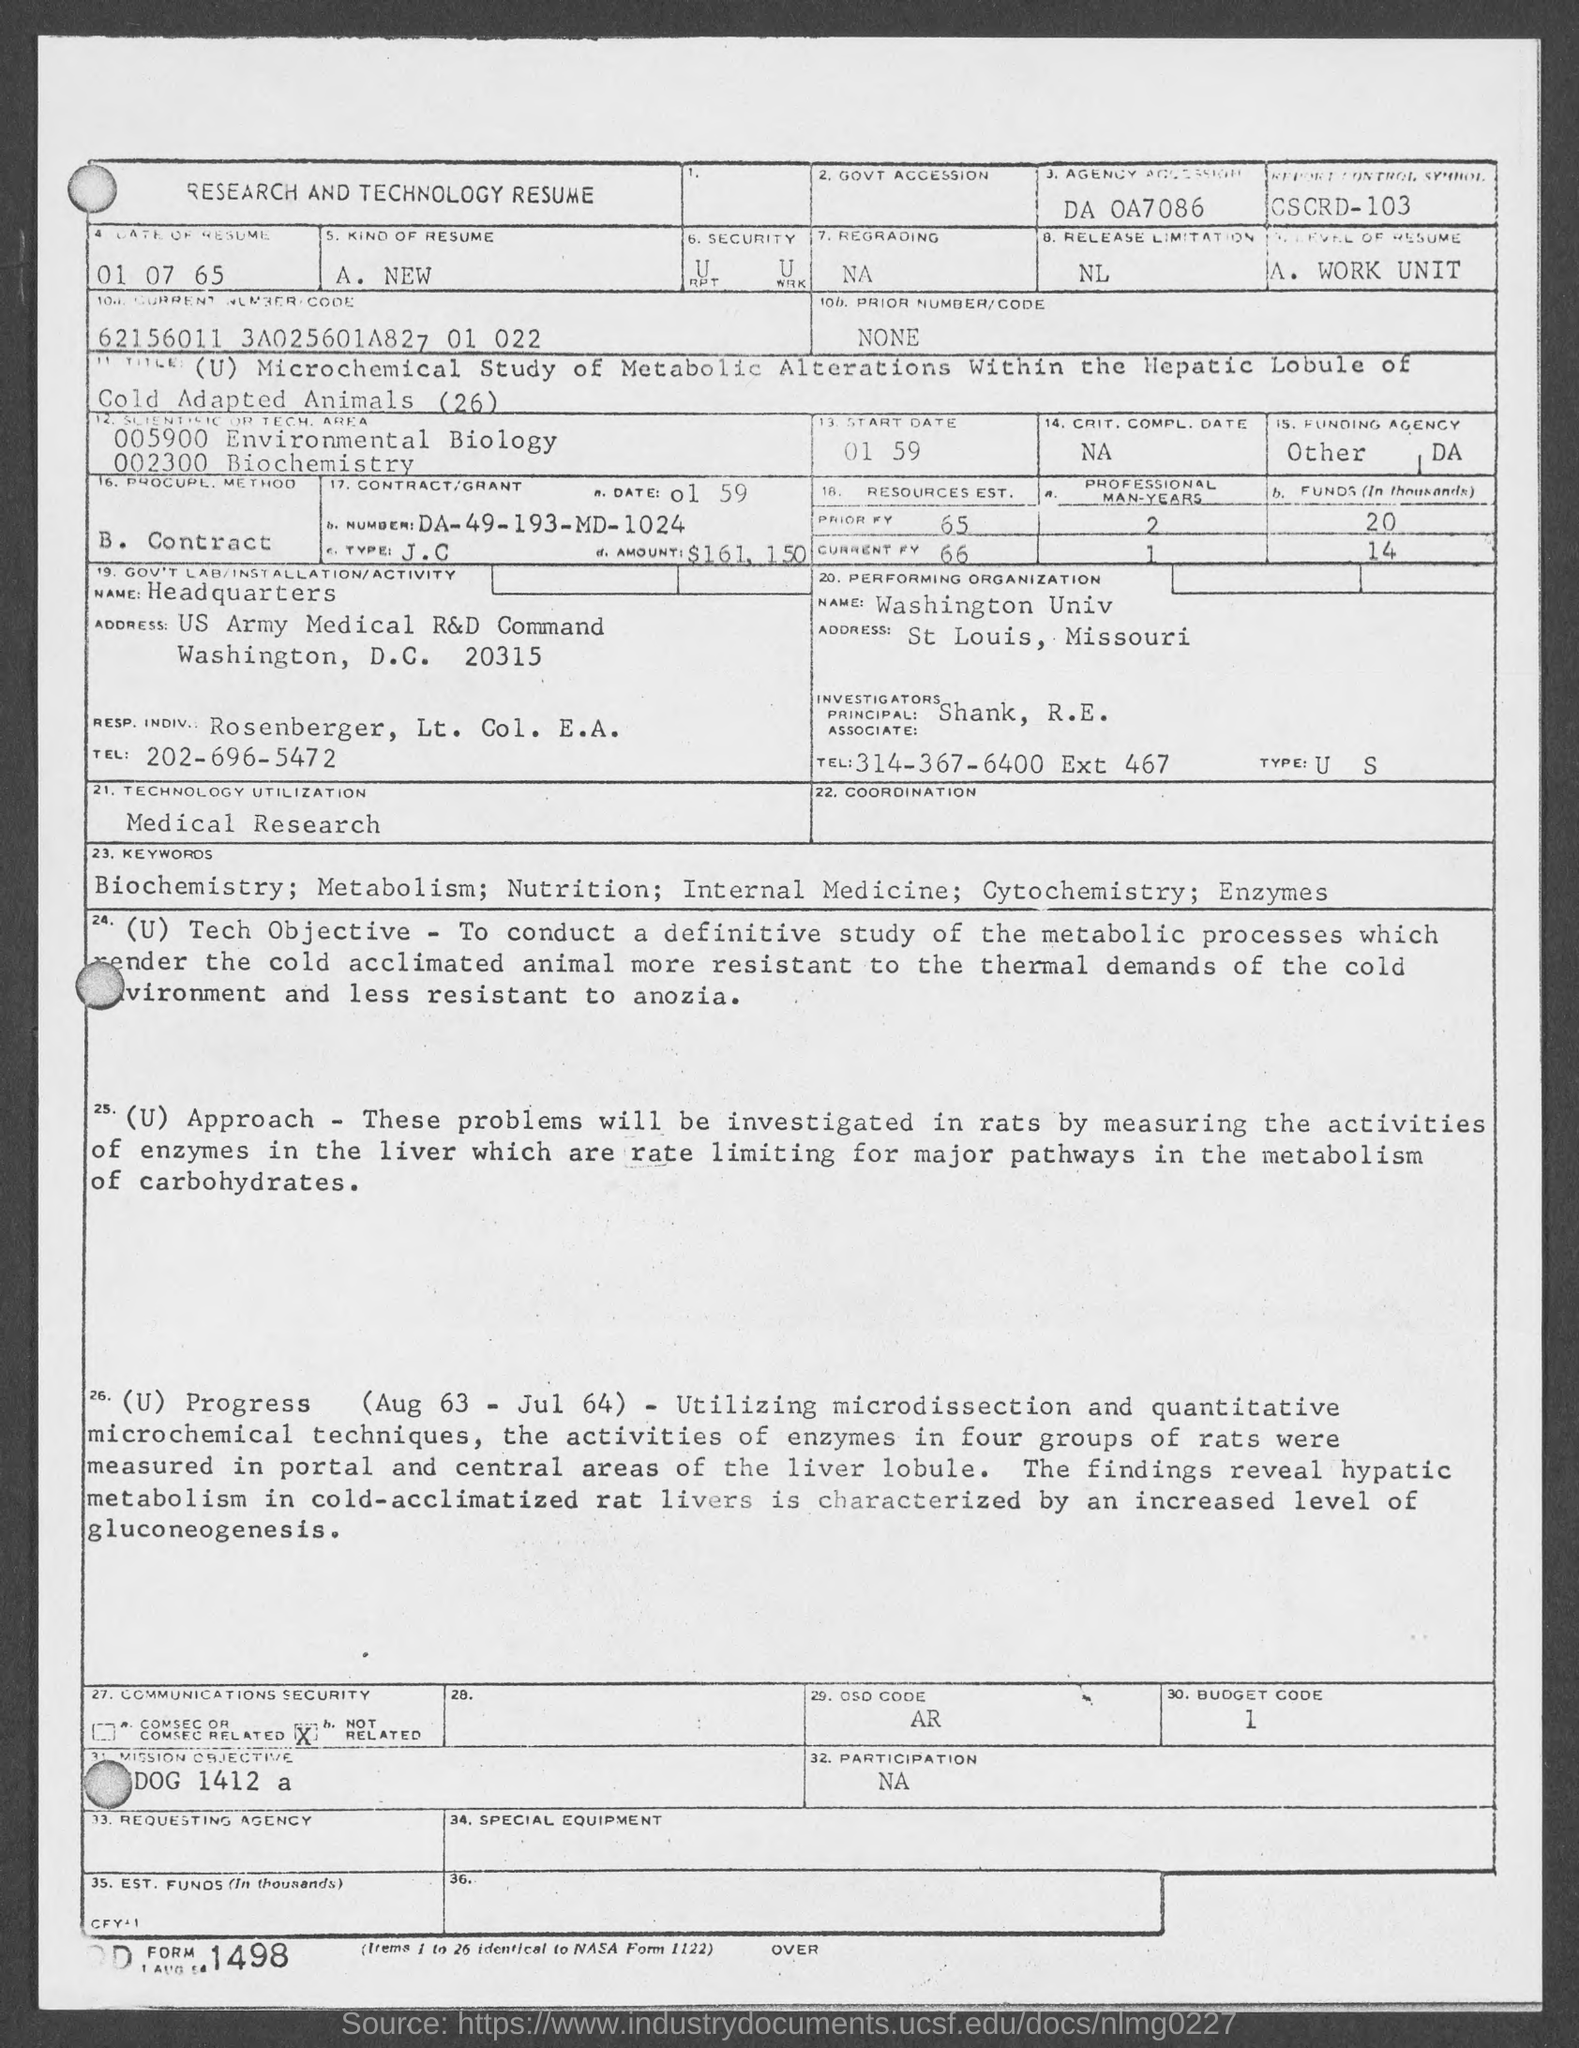List a handful of essential elements in this visual. The date of the resume mentioned in the document is July 1, 1965. The contract number given in the resume is DA-49-193-MD-1024. The Principal Investigator mentioned in the resume is R.E. Shank. The organization that is performing well according to the resume is Washington University. 